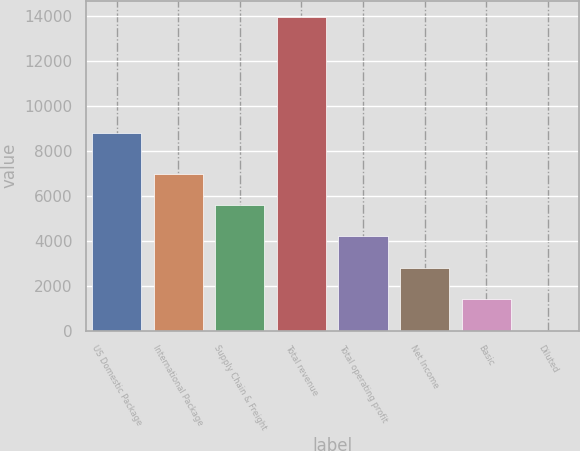<chart> <loc_0><loc_0><loc_500><loc_500><bar_chart><fcel>US Domestic Package<fcel>International Package<fcel>Supply Chain & Freight<fcel>Total revenue<fcel>Total operating profit<fcel>Net Income<fcel>Basic<fcel>Diluted<nl><fcel>8814<fcel>6989.07<fcel>5591.48<fcel>13977<fcel>4193.89<fcel>2796.3<fcel>1398.71<fcel>1.12<nl></chart> 